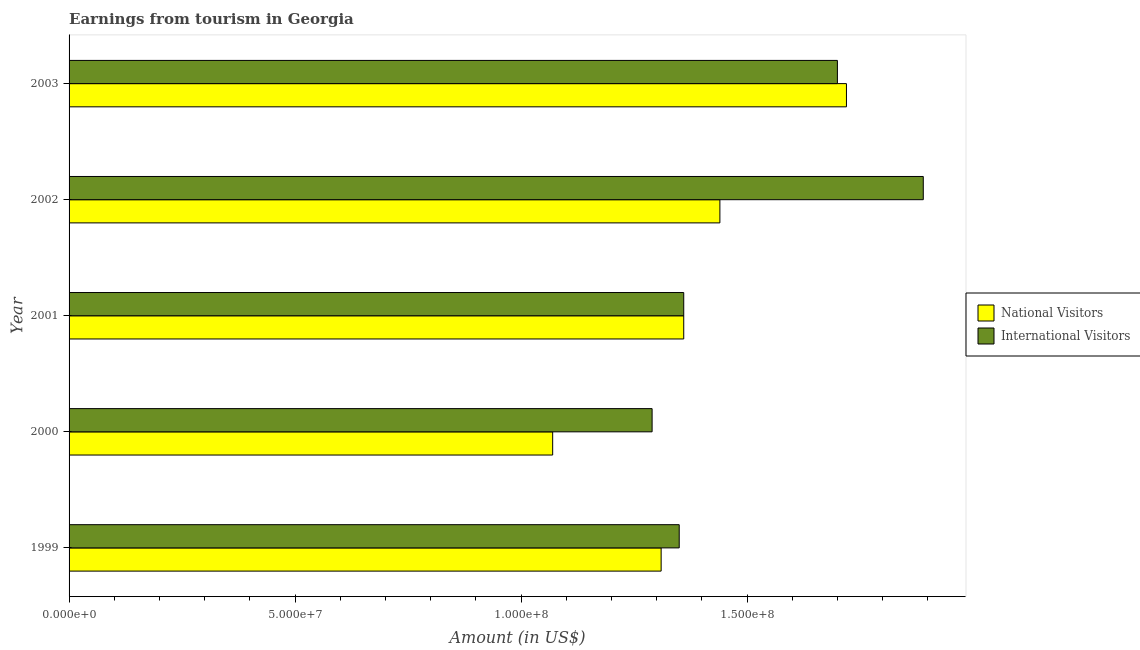How many different coloured bars are there?
Your response must be concise. 2. How many bars are there on the 3rd tick from the bottom?
Provide a succinct answer. 2. In how many cases, is the number of bars for a given year not equal to the number of legend labels?
Your response must be concise. 0. What is the amount earned from international visitors in 2001?
Your answer should be compact. 1.36e+08. Across all years, what is the maximum amount earned from international visitors?
Your answer should be very brief. 1.89e+08. Across all years, what is the minimum amount earned from international visitors?
Provide a succinct answer. 1.29e+08. In which year was the amount earned from international visitors maximum?
Offer a terse response. 2002. In which year was the amount earned from international visitors minimum?
Make the answer very short. 2000. What is the total amount earned from national visitors in the graph?
Make the answer very short. 6.90e+08. What is the difference between the amount earned from international visitors in 1999 and that in 2000?
Keep it short and to the point. 6.00e+06. What is the difference between the amount earned from national visitors in 1999 and the amount earned from international visitors in 2000?
Your answer should be very brief. 2.00e+06. What is the average amount earned from international visitors per year?
Offer a very short reply. 1.52e+08. In the year 2003, what is the difference between the amount earned from international visitors and amount earned from national visitors?
Offer a very short reply. -2.00e+06. What is the ratio of the amount earned from national visitors in 2000 to that in 2003?
Your response must be concise. 0.62. What is the difference between the highest and the second highest amount earned from national visitors?
Provide a succinct answer. 2.80e+07. What is the difference between the highest and the lowest amount earned from national visitors?
Provide a succinct answer. 6.50e+07. In how many years, is the amount earned from national visitors greater than the average amount earned from national visitors taken over all years?
Your answer should be compact. 2. Is the sum of the amount earned from international visitors in 2000 and 2003 greater than the maximum amount earned from national visitors across all years?
Provide a short and direct response. Yes. What does the 1st bar from the top in 2000 represents?
Make the answer very short. International Visitors. What does the 1st bar from the bottom in 2003 represents?
Provide a short and direct response. National Visitors. Are all the bars in the graph horizontal?
Keep it short and to the point. Yes. How many years are there in the graph?
Make the answer very short. 5. What is the difference between two consecutive major ticks on the X-axis?
Keep it short and to the point. 5.00e+07. Does the graph contain any zero values?
Make the answer very short. No. Does the graph contain grids?
Make the answer very short. No. What is the title of the graph?
Your response must be concise. Earnings from tourism in Georgia. Does "Education" appear as one of the legend labels in the graph?
Make the answer very short. No. What is the label or title of the Y-axis?
Keep it short and to the point. Year. What is the Amount (in US$) in National Visitors in 1999?
Provide a short and direct response. 1.31e+08. What is the Amount (in US$) in International Visitors in 1999?
Provide a short and direct response. 1.35e+08. What is the Amount (in US$) in National Visitors in 2000?
Your response must be concise. 1.07e+08. What is the Amount (in US$) in International Visitors in 2000?
Offer a terse response. 1.29e+08. What is the Amount (in US$) of National Visitors in 2001?
Provide a short and direct response. 1.36e+08. What is the Amount (in US$) in International Visitors in 2001?
Offer a very short reply. 1.36e+08. What is the Amount (in US$) in National Visitors in 2002?
Your answer should be compact. 1.44e+08. What is the Amount (in US$) in International Visitors in 2002?
Offer a very short reply. 1.89e+08. What is the Amount (in US$) of National Visitors in 2003?
Ensure brevity in your answer.  1.72e+08. What is the Amount (in US$) in International Visitors in 2003?
Provide a succinct answer. 1.70e+08. Across all years, what is the maximum Amount (in US$) of National Visitors?
Your response must be concise. 1.72e+08. Across all years, what is the maximum Amount (in US$) in International Visitors?
Provide a succinct answer. 1.89e+08. Across all years, what is the minimum Amount (in US$) of National Visitors?
Provide a succinct answer. 1.07e+08. Across all years, what is the minimum Amount (in US$) in International Visitors?
Ensure brevity in your answer.  1.29e+08. What is the total Amount (in US$) in National Visitors in the graph?
Keep it short and to the point. 6.90e+08. What is the total Amount (in US$) of International Visitors in the graph?
Give a very brief answer. 7.59e+08. What is the difference between the Amount (in US$) of National Visitors in 1999 and that in 2000?
Offer a very short reply. 2.40e+07. What is the difference between the Amount (in US$) of National Visitors in 1999 and that in 2001?
Your answer should be compact. -5.00e+06. What is the difference between the Amount (in US$) in International Visitors in 1999 and that in 2001?
Provide a succinct answer. -1.00e+06. What is the difference between the Amount (in US$) in National Visitors in 1999 and that in 2002?
Ensure brevity in your answer.  -1.30e+07. What is the difference between the Amount (in US$) in International Visitors in 1999 and that in 2002?
Provide a short and direct response. -5.40e+07. What is the difference between the Amount (in US$) in National Visitors in 1999 and that in 2003?
Keep it short and to the point. -4.10e+07. What is the difference between the Amount (in US$) of International Visitors in 1999 and that in 2003?
Provide a short and direct response. -3.50e+07. What is the difference between the Amount (in US$) in National Visitors in 2000 and that in 2001?
Keep it short and to the point. -2.90e+07. What is the difference between the Amount (in US$) of International Visitors in 2000 and that in 2001?
Ensure brevity in your answer.  -7.00e+06. What is the difference between the Amount (in US$) of National Visitors in 2000 and that in 2002?
Keep it short and to the point. -3.70e+07. What is the difference between the Amount (in US$) of International Visitors in 2000 and that in 2002?
Offer a very short reply. -6.00e+07. What is the difference between the Amount (in US$) of National Visitors in 2000 and that in 2003?
Your response must be concise. -6.50e+07. What is the difference between the Amount (in US$) in International Visitors in 2000 and that in 2003?
Keep it short and to the point. -4.10e+07. What is the difference between the Amount (in US$) in National Visitors in 2001 and that in 2002?
Your answer should be compact. -8.00e+06. What is the difference between the Amount (in US$) of International Visitors in 2001 and that in 2002?
Give a very brief answer. -5.30e+07. What is the difference between the Amount (in US$) of National Visitors in 2001 and that in 2003?
Keep it short and to the point. -3.60e+07. What is the difference between the Amount (in US$) in International Visitors in 2001 and that in 2003?
Ensure brevity in your answer.  -3.40e+07. What is the difference between the Amount (in US$) in National Visitors in 2002 and that in 2003?
Provide a succinct answer. -2.80e+07. What is the difference between the Amount (in US$) of International Visitors in 2002 and that in 2003?
Provide a short and direct response. 1.90e+07. What is the difference between the Amount (in US$) of National Visitors in 1999 and the Amount (in US$) of International Visitors in 2000?
Make the answer very short. 2.00e+06. What is the difference between the Amount (in US$) of National Visitors in 1999 and the Amount (in US$) of International Visitors in 2001?
Offer a very short reply. -5.00e+06. What is the difference between the Amount (in US$) of National Visitors in 1999 and the Amount (in US$) of International Visitors in 2002?
Provide a succinct answer. -5.80e+07. What is the difference between the Amount (in US$) in National Visitors in 1999 and the Amount (in US$) in International Visitors in 2003?
Make the answer very short. -3.90e+07. What is the difference between the Amount (in US$) in National Visitors in 2000 and the Amount (in US$) in International Visitors in 2001?
Your response must be concise. -2.90e+07. What is the difference between the Amount (in US$) of National Visitors in 2000 and the Amount (in US$) of International Visitors in 2002?
Your answer should be very brief. -8.20e+07. What is the difference between the Amount (in US$) of National Visitors in 2000 and the Amount (in US$) of International Visitors in 2003?
Provide a succinct answer. -6.30e+07. What is the difference between the Amount (in US$) of National Visitors in 2001 and the Amount (in US$) of International Visitors in 2002?
Provide a succinct answer. -5.30e+07. What is the difference between the Amount (in US$) in National Visitors in 2001 and the Amount (in US$) in International Visitors in 2003?
Your response must be concise. -3.40e+07. What is the difference between the Amount (in US$) of National Visitors in 2002 and the Amount (in US$) of International Visitors in 2003?
Provide a short and direct response. -2.60e+07. What is the average Amount (in US$) of National Visitors per year?
Give a very brief answer. 1.38e+08. What is the average Amount (in US$) of International Visitors per year?
Your answer should be very brief. 1.52e+08. In the year 1999, what is the difference between the Amount (in US$) of National Visitors and Amount (in US$) of International Visitors?
Your answer should be compact. -4.00e+06. In the year 2000, what is the difference between the Amount (in US$) of National Visitors and Amount (in US$) of International Visitors?
Make the answer very short. -2.20e+07. In the year 2001, what is the difference between the Amount (in US$) in National Visitors and Amount (in US$) in International Visitors?
Make the answer very short. 0. In the year 2002, what is the difference between the Amount (in US$) of National Visitors and Amount (in US$) of International Visitors?
Provide a short and direct response. -4.50e+07. In the year 2003, what is the difference between the Amount (in US$) of National Visitors and Amount (in US$) of International Visitors?
Offer a very short reply. 2.00e+06. What is the ratio of the Amount (in US$) of National Visitors in 1999 to that in 2000?
Give a very brief answer. 1.22. What is the ratio of the Amount (in US$) of International Visitors in 1999 to that in 2000?
Provide a succinct answer. 1.05. What is the ratio of the Amount (in US$) of National Visitors in 1999 to that in 2001?
Your answer should be very brief. 0.96. What is the ratio of the Amount (in US$) in National Visitors in 1999 to that in 2002?
Your response must be concise. 0.91. What is the ratio of the Amount (in US$) in National Visitors in 1999 to that in 2003?
Ensure brevity in your answer.  0.76. What is the ratio of the Amount (in US$) of International Visitors in 1999 to that in 2003?
Provide a short and direct response. 0.79. What is the ratio of the Amount (in US$) of National Visitors in 2000 to that in 2001?
Your answer should be very brief. 0.79. What is the ratio of the Amount (in US$) in International Visitors in 2000 to that in 2001?
Ensure brevity in your answer.  0.95. What is the ratio of the Amount (in US$) of National Visitors in 2000 to that in 2002?
Provide a short and direct response. 0.74. What is the ratio of the Amount (in US$) in International Visitors in 2000 to that in 2002?
Provide a short and direct response. 0.68. What is the ratio of the Amount (in US$) in National Visitors in 2000 to that in 2003?
Provide a succinct answer. 0.62. What is the ratio of the Amount (in US$) of International Visitors in 2000 to that in 2003?
Offer a terse response. 0.76. What is the ratio of the Amount (in US$) of International Visitors in 2001 to that in 2002?
Offer a very short reply. 0.72. What is the ratio of the Amount (in US$) in National Visitors in 2001 to that in 2003?
Give a very brief answer. 0.79. What is the ratio of the Amount (in US$) of National Visitors in 2002 to that in 2003?
Make the answer very short. 0.84. What is the ratio of the Amount (in US$) in International Visitors in 2002 to that in 2003?
Your response must be concise. 1.11. What is the difference between the highest and the second highest Amount (in US$) of National Visitors?
Your answer should be compact. 2.80e+07. What is the difference between the highest and the second highest Amount (in US$) in International Visitors?
Provide a succinct answer. 1.90e+07. What is the difference between the highest and the lowest Amount (in US$) in National Visitors?
Your answer should be compact. 6.50e+07. What is the difference between the highest and the lowest Amount (in US$) in International Visitors?
Your answer should be compact. 6.00e+07. 